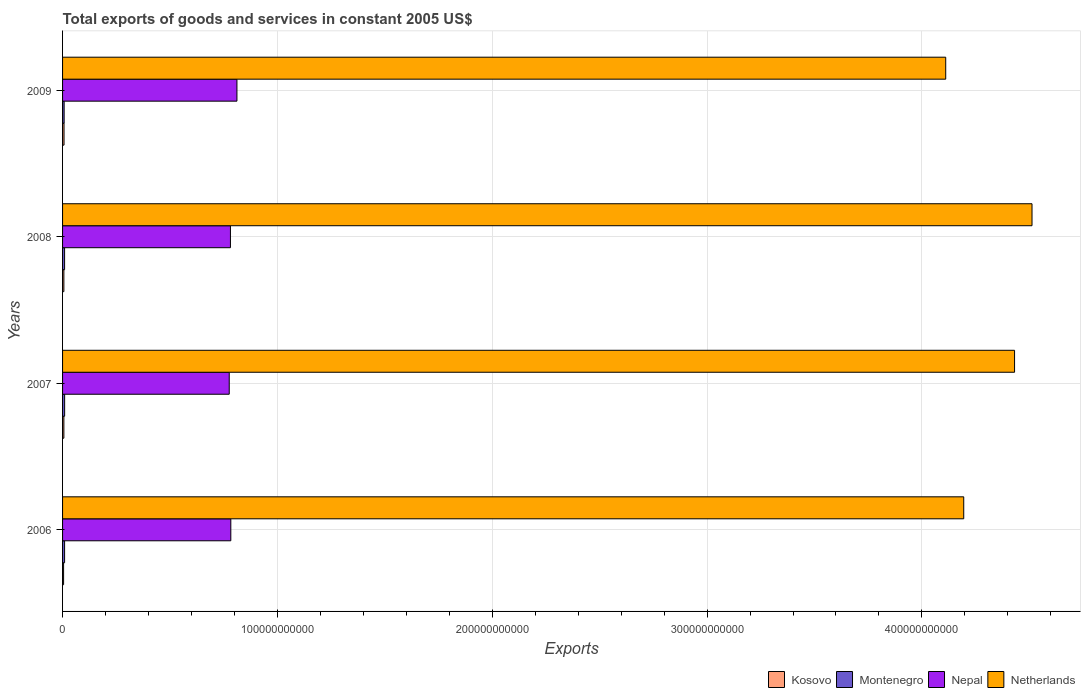How many different coloured bars are there?
Offer a terse response. 4. How many groups of bars are there?
Offer a terse response. 4. Are the number of bars on each tick of the Y-axis equal?
Make the answer very short. Yes. How many bars are there on the 1st tick from the top?
Give a very brief answer. 4. How many bars are there on the 1st tick from the bottom?
Your answer should be very brief. 4. What is the label of the 3rd group of bars from the top?
Your response must be concise. 2007. In how many cases, is the number of bars for a given year not equal to the number of legend labels?
Provide a short and direct response. 0. What is the total exports of goods and services in Nepal in 2006?
Provide a succinct answer. 7.83e+1. Across all years, what is the maximum total exports of goods and services in Kosovo?
Your response must be concise. 6.85e+08. Across all years, what is the minimum total exports of goods and services in Nepal?
Give a very brief answer. 7.76e+1. In which year was the total exports of goods and services in Nepal maximum?
Keep it short and to the point. 2009. In which year was the total exports of goods and services in Kosovo minimum?
Offer a very short reply. 2006. What is the total total exports of goods and services in Kosovo in the graph?
Provide a succinct answer. 2.38e+09. What is the difference between the total exports of goods and services in Montenegro in 2007 and that in 2008?
Your response must be concise. 1.98e+07. What is the difference between the total exports of goods and services in Netherlands in 2006 and the total exports of goods and services in Nepal in 2009?
Make the answer very short. 3.38e+11. What is the average total exports of goods and services in Kosovo per year?
Provide a succinct answer. 5.96e+08. In the year 2008, what is the difference between the total exports of goods and services in Kosovo and total exports of goods and services in Montenegro?
Your answer should be very brief. -3.37e+08. What is the ratio of the total exports of goods and services in Kosovo in 2007 to that in 2008?
Your answer should be very brief. 1. What is the difference between the highest and the second highest total exports of goods and services in Kosovo?
Provide a succinct answer. 7.59e+07. What is the difference between the highest and the lowest total exports of goods and services in Montenegro?
Provide a short and direct response. 2.31e+08. What does the 4th bar from the top in 2006 represents?
Offer a very short reply. Kosovo. What does the 1st bar from the bottom in 2008 represents?
Your response must be concise. Kosovo. Is it the case that in every year, the sum of the total exports of goods and services in Netherlands and total exports of goods and services in Nepal is greater than the total exports of goods and services in Montenegro?
Ensure brevity in your answer.  Yes. How many bars are there?
Your answer should be compact. 16. Are all the bars in the graph horizontal?
Your answer should be compact. Yes. How many years are there in the graph?
Ensure brevity in your answer.  4. What is the difference between two consecutive major ticks on the X-axis?
Your response must be concise. 1.00e+11. Are the values on the major ticks of X-axis written in scientific E-notation?
Ensure brevity in your answer.  No. Does the graph contain any zero values?
Your answer should be very brief. No. Where does the legend appear in the graph?
Keep it short and to the point. Bottom right. How are the legend labels stacked?
Your response must be concise. Horizontal. What is the title of the graph?
Provide a succinct answer. Total exports of goods and services in constant 2005 US$. Does "Low income" appear as one of the legend labels in the graph?
Provide a succinct answer. No. What is the label or title of the X-axis?
Offer a terse response. Exports. What is the Exports in Kosovo in 2006?
Your response must be concise. 4.81e+08. What is the Exports in Montenegro in 2006?
Offer a terse response. 9.46e+08. What is the Exports of Nepal in 2006?
Your answer should be very brief. 7.83e+1. What is the Exports in Netherlands in 2006?
Your answer should be compact. 4.19e+11. What is the Exports in Kosovo in 2007?
Provide a succinct answer. 6.08e+08. What is the Exports of Montenegro in 2007?
Make the answer very short. 9.66e+08. What is the Exports in Nepal in 2007?
Your response must be concise. 7.76e+1. What is the Exports in Netherlands in 2007?
Ensure brevity in your answer.  4.43e+11. What is the Exports of Kosovo in 2008?
Make the answer very short. 6.09e+08. What is the Exports in Montenegro in 2008?
Provide a short and direct response. 9.46e+08. What is the Exports in Nepal in 2008?
Give a very brief answer. 7.81e+1. What is the Exports in Netherlands in 2008?
Ensure brevity in your answer.  4.51e+11. What is the Exports of Kosovo in 2009?
Your answer should be compact. 6.85e+08. What is the Exports of Montenegro in 2009?
Make the answer very short. 7.35e+08. What is the Exports in Nepal in 2009?
Provide a short and direct response. 8.12e+1. What is the Exports in Netherlands in 2009?
Make the answer very short. 4.11e+11. Across all years, what is the maximum Exports of Kosovo?
Give a very brief answer. 6.85e+08. Across all years, what is the maximum Exports of Montenegro?
Make the answer very short. 9.66e+08. Across all years, what is the maximum Exports of Nepal?
Make the answer very short. 8.12e+1. Across all years, what is the maximum Exports of Netherlands?
Offer a very short reply. 4.51e+11. Across all years, what is the minimum Exports in Kosovo?
Provide a short and direct response. 4.81e+08. Across all years, what is the minimum Exports in Montenegro?
Offer a very short reply. 7.35e+08. Across all years, what is the minimum Exports of Nepal?
Your response must be concise. 7.76e+1. Across all years, what is the minimum Exports in Netherlands?
Your response must be concise. 4.11e+11. What is the total Exports of Kosovo in the graph?
Offer a terse response. 2.38e+09. What is the total Exports in Montenegro in the graph?
Ensure brevity in your answer.  3.59e+09. What is the total Exports of Nepal in the graph?
Offer a very short reply. 3.15e+11. What is the total Exports of Netherlands in the graph?
Your response must be concise. 1.72e+12. What is the difference between the Exports of Kosovo in 2006 and that in 2007?
Provide a succinct answer. -1.27e+08. What is the difference between the Exports in Montenegro in 2006 and that in 2007?
Your response must be concise. -2.01e+07. What is the difference between the Exports of Nepal in 2006 and that in 2007?
Give a very brief answer. 7.40e+08. What is the difference between the Exports of Netherlands in 2006 and that in 2007?
Your answer should be compact. -2.37e+1. What is the difference between the Exports in Kosovo in 2006 and that in 2008?
Offer a very short reply. -1.28e+08. What is the difference between the Exports of Montenegro in 2006 and that in 2008?
Make the answer very short. -3.10e+05. What is the difference between the Exports in Nepal in 2006 and that in 2008?
Provide a succinct answer. 1.76e+08. What is the difference between the Exports in Netherlands in 2006 and that in 2008?
Your response must be concise. -3.18e+1. What is the difference between the Exports in Kosovo in 2006 and that in 2009?
Make the answer very short. -2.03e+08. What is the difference between the Exports in Montenegro in 2006 and that in 2009?
Keep it short and to the point. 2.11e+08. What is the difference between the Exports of Nepal in 2006 and that in 2009?
Offer a very short reply. -2.85e+09. What is the difference between the Exports of Netherlands in 2006 and that in 2009?
Provide a succinct answer. 8.39e+09. What is the difference between the Exports of Kosovo in 2007 and that in 2008?
Your answer should be very brief. -5.00e+05. What is the difference between the Exports in Montenegro in 2007 and that in 2008?
Ensure brevity in your answer.  1.98e+07. What is the difference between the Exports in Nepal in 2007 and that in 2008?
Your answer should be compact. -5.64e+08. What is the difference between the Exports in Netherlands in 2007 and that in 2008?
Ensure brevity in your answer.  -8.13e+09. What is the difference between the Exports of Kosovo in 2007 and that in 2009?
Make the answer very short. -7.64e+07. What is the difference between the Exports in Montenegro in 2007 and that in 2009?
Give a very brief answer. 2.31e+08. What is the difference between the Exports in Nepal in 2007 and that in 2009?
Your answer should be very brief. -3.59e+09. What is the difference between the Exports of Netherlands in 2007 and that in 2009?
Keep it short and to the point. 3.20e+1. What is the difference between the Exports in Kosovo in 2008 and that in 2009?
Offer a terse response. -7.59e+07. What is the difference between the Exports of Montenegro in 2008 and that in 2009?
Your answer should be very brief. 2.11e+08. What is the difference between the Exports in Nepal in 2008 and that in 2009?
Give a very brief answer. -3.03e+09. What is the difference between the Exports in Netherlands in 2008 and that in 2009?
Your response must be concise. 4.02e+1. What is the difference between the Exports in Kosovo in 2006 and the Exports in Montenegro in 2007?
Provide a succinct answer. -4.85e+08. What is the difference between the Exports of Kosovo in 2006 and the Exports of Nepal in 2007?
Make the answer very short. -7.71e+1. What is the difference between the Exports of Kosovo in 2006 and the Exports of Netherlands in 2007?
Offer a very short reply. -4.43e+11. What is the difference between the Exports in Montenegro in 2006 and the Exports in Nepal in 2007?
Offer a terse response. -7.66e+1. What is the difference between the Exports in Montenegro in 2006 and the Exports in Netherlands in 2007?
Make the answer very short. -4.42e+11. What is the difference between the Exports of Nepal in 2006 and the Exports of Netherlands in 2007?
Ensure brevity in your answer.  -3.65e+11. What is the difference between the Exports in Kosovo in 2006 and the Exports in Montenegro in 2008?
Offer a very short reply. -4.65e+08. What is the difference between the Exports in Kosovo in 2006 and the Exports in Nepal in 2008?
Offer a terse response. -7.77e+1. What is the difference between the Exports of Kosovo in 2006 and the Exports of Netherlands in 2008?
Provide a short and direct response. -4.51e+11. What is the difference between the Exports of Montenegro in 2006 and the Exports of Nepal in 2008?
Ensure brevity in your answer.  -7.72e+1. What is the difference between the Exports of Montenegro in 2006 and the Exports of Netherlands in 2008?
Make the answer very short. -4.50e+11. What is the difference between the Exports in Nepal in 2006 and the Exports in Netherlands in 2008?
Offer a very short reply. -3.73e+11. What is the difference between the Exports in Kosovo in 2006 and the Exports in Montenegro in 2009?
Your answer should be very brief. -2.53e+08. What is the difference between the Exports of Kosovo in 2006 and the Exports of Nepal in 2009?
Make the answer very short. -8.07e+1. What is the difference between the Exports of Kosovo in 2006 and the Exports of Netherlands in 2009?
Make the answer very short. -4.11e+11. What is the difference between the Exports in Montenegro in 2006 and the Exports in Nepal in 2009?
Keep it short and to the point. -8.02e+1. What is the difference between the Exports of Montenegro in 2006 and the Exports of Netherlands in 2009?
Make the answer very short. -4.10e+11. What is the difference between the Exports in Nepal in 2006 and the Exports in Netherlands in 2009?
Offer a very short reply. -3.33e+11. What is the difference between the Exports in Kosovo in 2007 and the Exports in Montenegro in 2008?
Offer a very short reply. -3.38e+08. What is the difference between the Exports of Kosovo in 2007 and the Exports of Nepal in 2008?
Provide a succinct answer. -7.75e+1. What is the difference between the Exports of Kosovo in 2007 and the Exports of Netherlands in 2008?
Make the answer very short. -4.51e+11. What is the difference between the Exports of Montenegro in 2007 and the Exports of Nepal in 2008?
Provide a short and direct response. -7.72e+1. What is the difference between the Exports of Montenegro in 2007 and the Exports of Netherlands in 2008?
Your answer should be very brief. -4.50e+11. What is the difference between the Exports in Nepal in 2007 and the Exports in Netherlands in 2008?
Offer a very short reply. -3.74e+11. What is the difference between the Exports in Kosovo in 2007 and the Exports in Montenegro in 2009?
Your answer should be very brief. -1.26e+08. What is the difference between the Exports of Kosovo in 2007 and the Exports of Nepal in 2009?
Provide a short and direct response. -8.06e+1. What is the difference between the Exports in Kosovo in 2007 and the Exports in Netherlands in 2009?
Provide a short and direct response. -4.10e+11. What is the difference between the Exports of Montenegro in 2007 and the Exports of Nepal in 2009?
Your answer should be compact. -8.02e+1. What is the difference between the Exports of Montenegro in 2007 and the Exports of Netherlands in 2009?
Give a very brief answer. -4.10e+11. What is the difference between the Exports in Nepal in 2007 and the Exports in Netherlands in 2009?
Provide a short and direct response. -3.34e+11. What is the difference between the Exports of Kosovo in 2008 and the Exports of Montenegro in 2009?
Ensure brevity in your answer.  -1.26e+08. What is the difference between the Exports in Kosovo in 2008 and the Exports in Nepal in 2009?
Give a very brief answer. -8.06e+1. What is the difference between the Exports of Kosovo in 2008 and the Exports of Netherlands in 2009?
Offer a very short reply. -4.10e+11. What is the difference between the Exports of Montenegro in 2008 and the Exports of Nepal in 2009?
Make the answer very short. -8.02e+1. What is the difference between the Exports in Montenegro in 2008 and the Exports in Netherlands in 2009?
Provide a short and direct response. -4.10e+11. What is the difference between the Exports in Nepal in 2008 and the Exports in Netherlands in 2009?
Your answer should be compact. -3.33e+11. What is the average Exports of Kosovo per year?
Make the answer very short. 5.96e+08. What is the average Exports in Montenegro per year?
Keep it short and to the point. 8.98e+08. What is the average Exports of Nepal per year?
Offer a very short reply. 7.88e+1. What is the average Exports in Netherlands per year?
Your response must be concise. 4.31e+11. In the year 2006, what is the difference between the Exports in Kosovo and Exports in Montenegro?
Ensure brevity in your answer.  -4.64e+08. In the year 2006, what is the difference between the Exports in Kosovo and Exports in Nepal?
Your answer should be very brief. -7.78e+1. In the year 2006, what is the difference between the Exports in Kosovo and Exports in Netherlands?
Your response must be concise. -4.19e+11. In the year 2006, what is the difference between the Exports of Montenegro and Exports of Nepal?
Your answer should be compact. -7.74e+1. In the year 2006, what is the difference between the Exports in Montenegro and Exports in Netherlands?
Offer a terse response. -4.19e+11. In the year 2006, what is the difference between the Exports of Nepal and Exports of Netherlands?
Offer a terse response. -3.41e+11. In the year 2007, what is the difference between the Exports in Kosovo and Exports in Montenegro?
Give a very brief answer. -3.58e+08. In the year 2007, what is the difference between the Exports of Kosovo and Exports of Nepal?
Provide a short and direct response. -7.70e+1. In the year 2007, what is the difference between the Exports in Kosovo and Exports in Netherlands?
Ensure brevity in your answer.  -4.43e+11. In the year 2007, what is the difference between the Exports of Montenegro and Exports of Nepal?
Provide a short and direct response. -7.66e+1. In the year 2007, what is the difference between the Exports in Montenegro and Exports in Netherlands?
Provide a short and direct response. -4.42e+11. In the year 2007, what is the difference between the Exports of Nepal and Exports of Netherlands?
Make the answer very short. -3.66e+11. In the year 2008, what is the difference between the Exports of Kosovo and Exports of Montenegro?
Provide a succinct answer. -3.37e+08. In the year 2008, what is the difference between the Exports in Kosovo and Exports in Nepal?
Your answer should be very brief. -7.75e+1. In the year 2008, what is the difference between the Exports of Kosovo and Exports of Netherlands?
Provide a succinct answer. -4.51e+11. In the year 2008, what is the difference between the Exports of Montenegro and Exports of Nepal?
Offer a very short reply. -7.72e+1. In the year 2008, what is the difference between the Exports of Montenegro and Exports of Netherlands?
Keep it short and to the point. -4.50e+11. In the year 2008, what is the difference between the Exports of Nepal and Exports of Netherlands?
Offer a very short reply. -3.73e+11. In the year 2009, what is the difference between the Exports of Kosovo and Exports of Montenegro?
Provide a short and direct response. -4.99e+07. In the year 2009, what is the difference between the Exports of Kosovo and Exports of Nepal?
Your answer should be compact. -8.05e+1. In the year 2009, what is the difference between the Exports in Kosovo and Exports in Netherlands?
Give a very brief answer. -4.10e+11. In the year 2009, what is the difference between the Exports in Montenegro and Exports in Nepal?
Offer a very short reply. -8.04e+1. In the year 2009, what is the difference between the Exports in Montenegro and Exports in Netherlands?
Give a very brief answer. -4.10e+11. In the year 2009, what is the difference between the Exports of Nepal and Exports of Netherlands?
Keep it short and to the point. -3.30e+11. What is the ratio of the Exports of Kosovo in 2006 to that in 2007?
Provide a succinct answer. 0.79. What is the ratio of the Exports of Montenegro in 2006 to that in 2007?
Give a very brief answer. 0.98. What is the ratio of the Exports in Nepal in 2006 to that in 2007?
Ensure brevity in your answer.  1.01. What is the ratio of the Exports of Netherlands in 2006 to that in 2007?
Keep it short and to the point. 0.95. What is the ratio of the Exports in Kosovo in 2006 to that in 2008?
Make the answer very short. 0.79. What is the ratio of the Exports in Nepal in 2006 to that in 2008?
Make the answer very short. 1. What is the ratio of the Exports of Netherlands in 2006 to that in 2008?
Offer a terse response. 0.93. What is the ratio of the Exports of Kosovo in 2006 to that in 2009?
Ensure brevity in your answer.  0.7. What is the ratio of the Exports in Montenegro in 2006 to that in 2009?
Keep it short and to the point. 1.29. What is the ratio of the Exports of Nepal in 2006 to that in 2009?
Offer a very short reply. 0.96. What is the ratio of the Exports in Netherlands in 2006 to that in 2009?
Offer a terse response. 1.02. What is the ratio of the Exports of Kosovo in 2007 to that in 2008?
Ensure brevity in your answer.  1. What is the ratio of the Exports in Montenegro in 2007 to that in 2008?
Keep it short and to the point. 1.02. What is the ratio of the Exports in Kosovo in 2007 to that in 2009?
Offer a very short reply. 0.89. What is the ratio of the Exports of Montenegro in 2007 to that in 2009?
Make the answer very short. 1.31. What is the ratio of the Exports in Nepal in 2007 to that in 2009?
Offer a terse response. 0.96. What is the ratio of the Exports in Netherlands in 2007 to that in 2009?
Give a very brief answer. 1.08. What is the ratio of the Exports of Kosovo in 2008 to that in 2009?
Ensure brevity in your answer.  0.89. What is the ratio of the Exports in Montenegro in 2008 to that in 2009?
Provide a short and direct response. 1.29. What is the ratio of the Exports of Nepal in 2008 to that in 2009?
Provide a short and direct response. 0.96. What is the ratio of the Exports of Netherlands in 2008 to that in 2009?
Provide a short and direct response. 1.1. What is the difference between the highest and the second highest Exports of Kosovo?
Provide a short and direct response. 7.59e+07. What is the difference between the highest and the second highest Exports of Montenegro?
Ensure brevity in your answer.  1.98e+07. What is the difference between the highest and the second highest Exports in Nepal?
Your answer should be very brief. 2.85e+09. What is the difference between the highest and the second highest Exports of Netherlands?
Provide a succinct answer. 8.13e+09. What is the difference between the highest and the lowest Exports of Kosovo?
Keep it short and to the point. 2.03e+08. What is the difference between the highest and the lowest Exports in Montenegro?
Provide a succinct answer. 2.31e+08. What is the difference between the highest and the lowest Exports of Nepal?
Offer a very short reply. 3.59e+09. What is the difference between the highest and the lowest Exports of Netherlands?
Offer a terse response. 4.02e+1. 